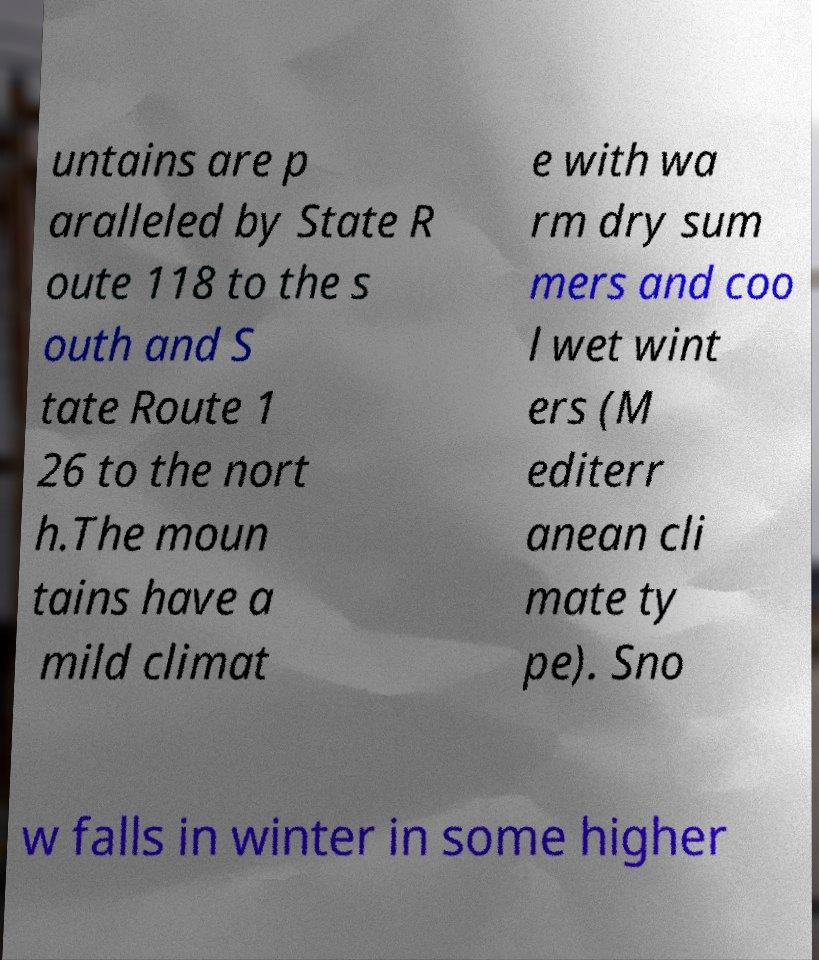I need the written content from this picture converted into text. Can you do that? untains are p aralleled by State R oute 118 to the s outh and S tate Route 1 26 to the nort h.The moun tains have a mild climat e with wa rm dry sum mers and coo l wet wint ers (M editerr anean cli mate ty pe). Sno w falls in winter in some higher 